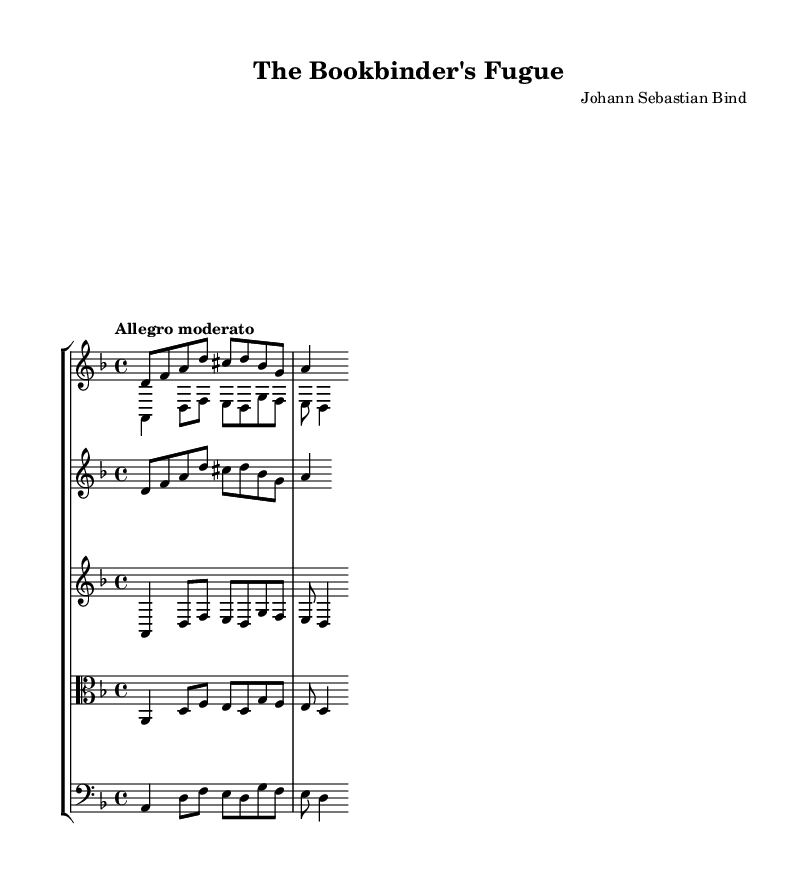What is the key signature of this music? The key signature is indicated by the sharps or flats at the beginning of the staff. In this case, it is D minor, which contains one flat (B♭).
Answer: D minor What is the time signature of this music? The time signature appears at the beginning of the music, indicating how many beats are in each measure. Here, it is 4/4, which means there are four beats per measure.
Answer: 4/4 What is the tempo marking of the piece? The tempo marking is located at the start of the music, indicating the speed at which it should be played. In this case, it is "Allegro moderato," which means moderately fast.
Answer: Allegro moderato How many voices are presented in the harpsichord staff? The harpsichord part contains two separate voices, indicated by the use of \voiceOne and \voiceTwo. This is characteristic of fugue composition as it features interweaving lines.
Answer: Two Which voice plays the main theme? The main theme is represented in the staff, and under the harpsichord section, it is specifically written in the \mainTheme. This theme is primarily in the first voice of the harpsichord.
Answer: First voice What is the function of the counter subject in this composition? The counter subject complements the main theme and is played simultaneously but has its unique melody, providing harmonic depth while adhering to the structure of a fugue. Its appearance within the staff supports the theme of bookbinding by layering themes akin to layered book covers.
Answer: Complementary harmony 